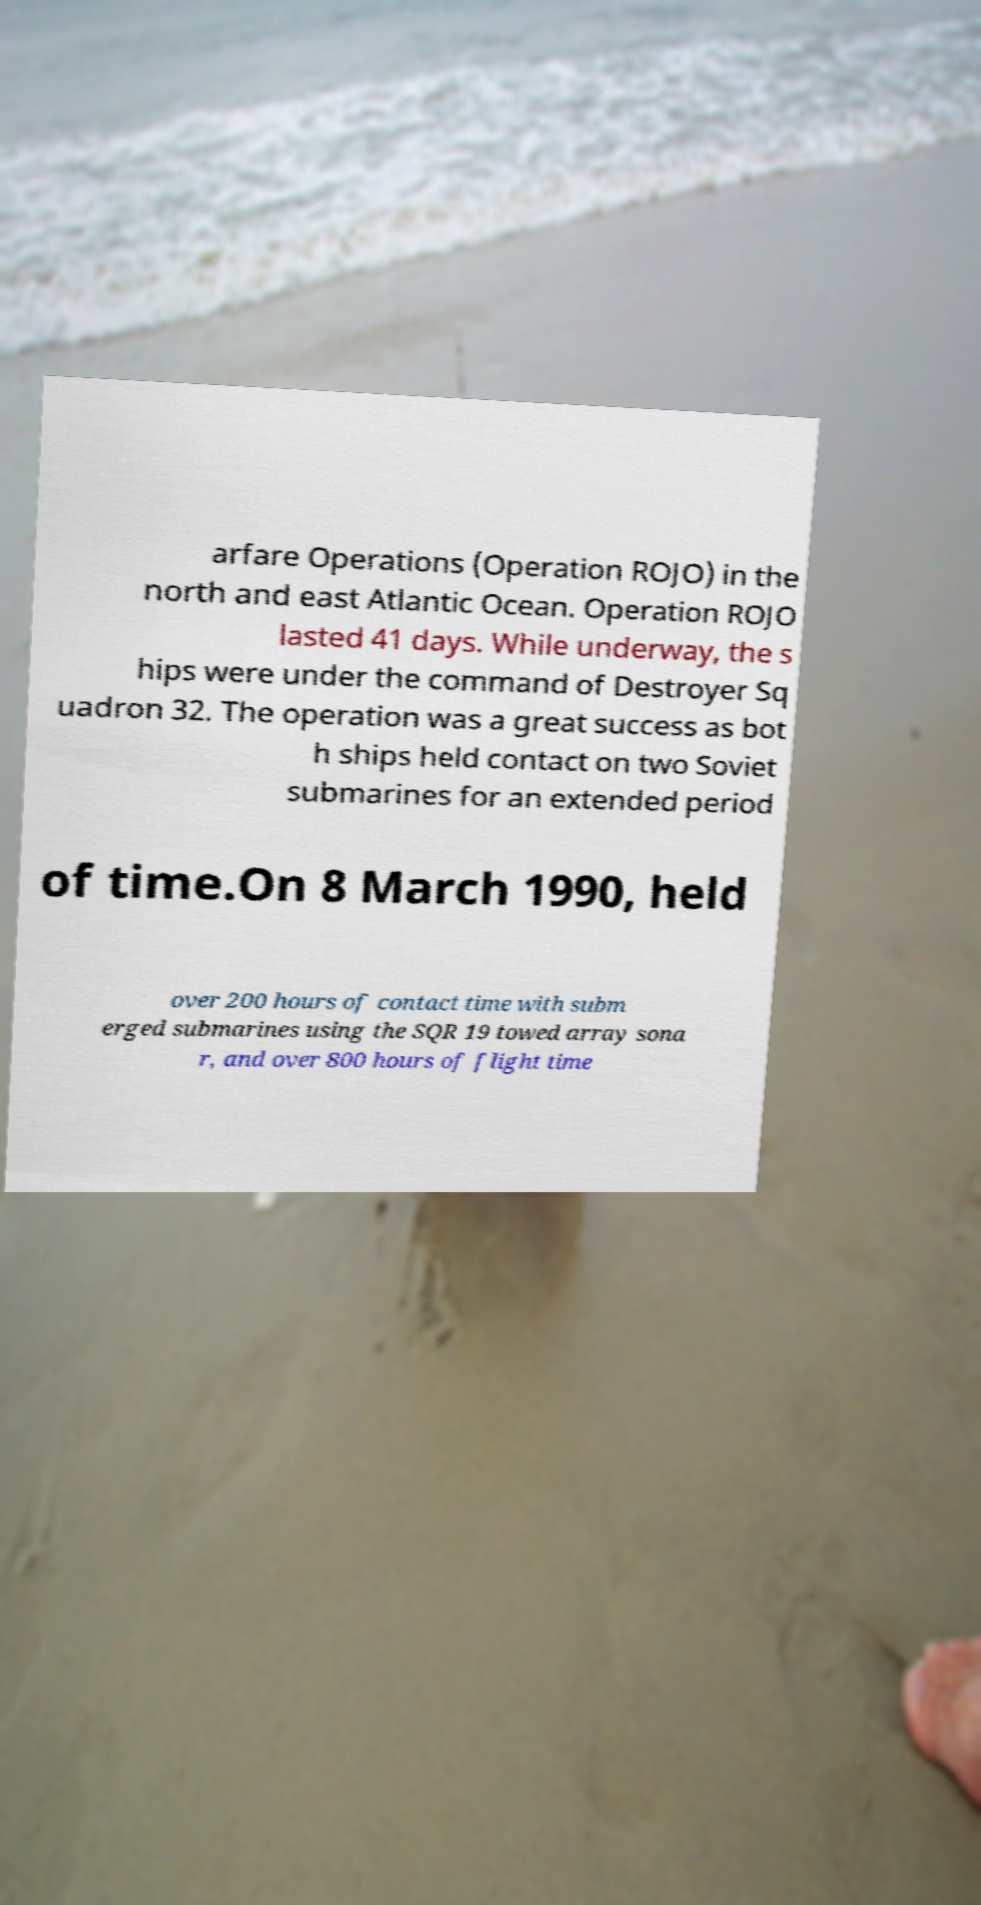I need the written content from this picture converted into text. Can you do that? arfare Operations (Operation ROJO) in the north and east Atlantic Ocean. Operation ROJO lasted 41 days. While underway, the s hips were under the command of Destroyer Sq uadron 32. The operation was a great success as bot h ships held contact on two Soviet submarines for an extended period of time.On 8 March 1990, held over 200 hours of contact time with subm erged submarines using the SQR 19 towed array sona r, and over 800 hours of flight time 